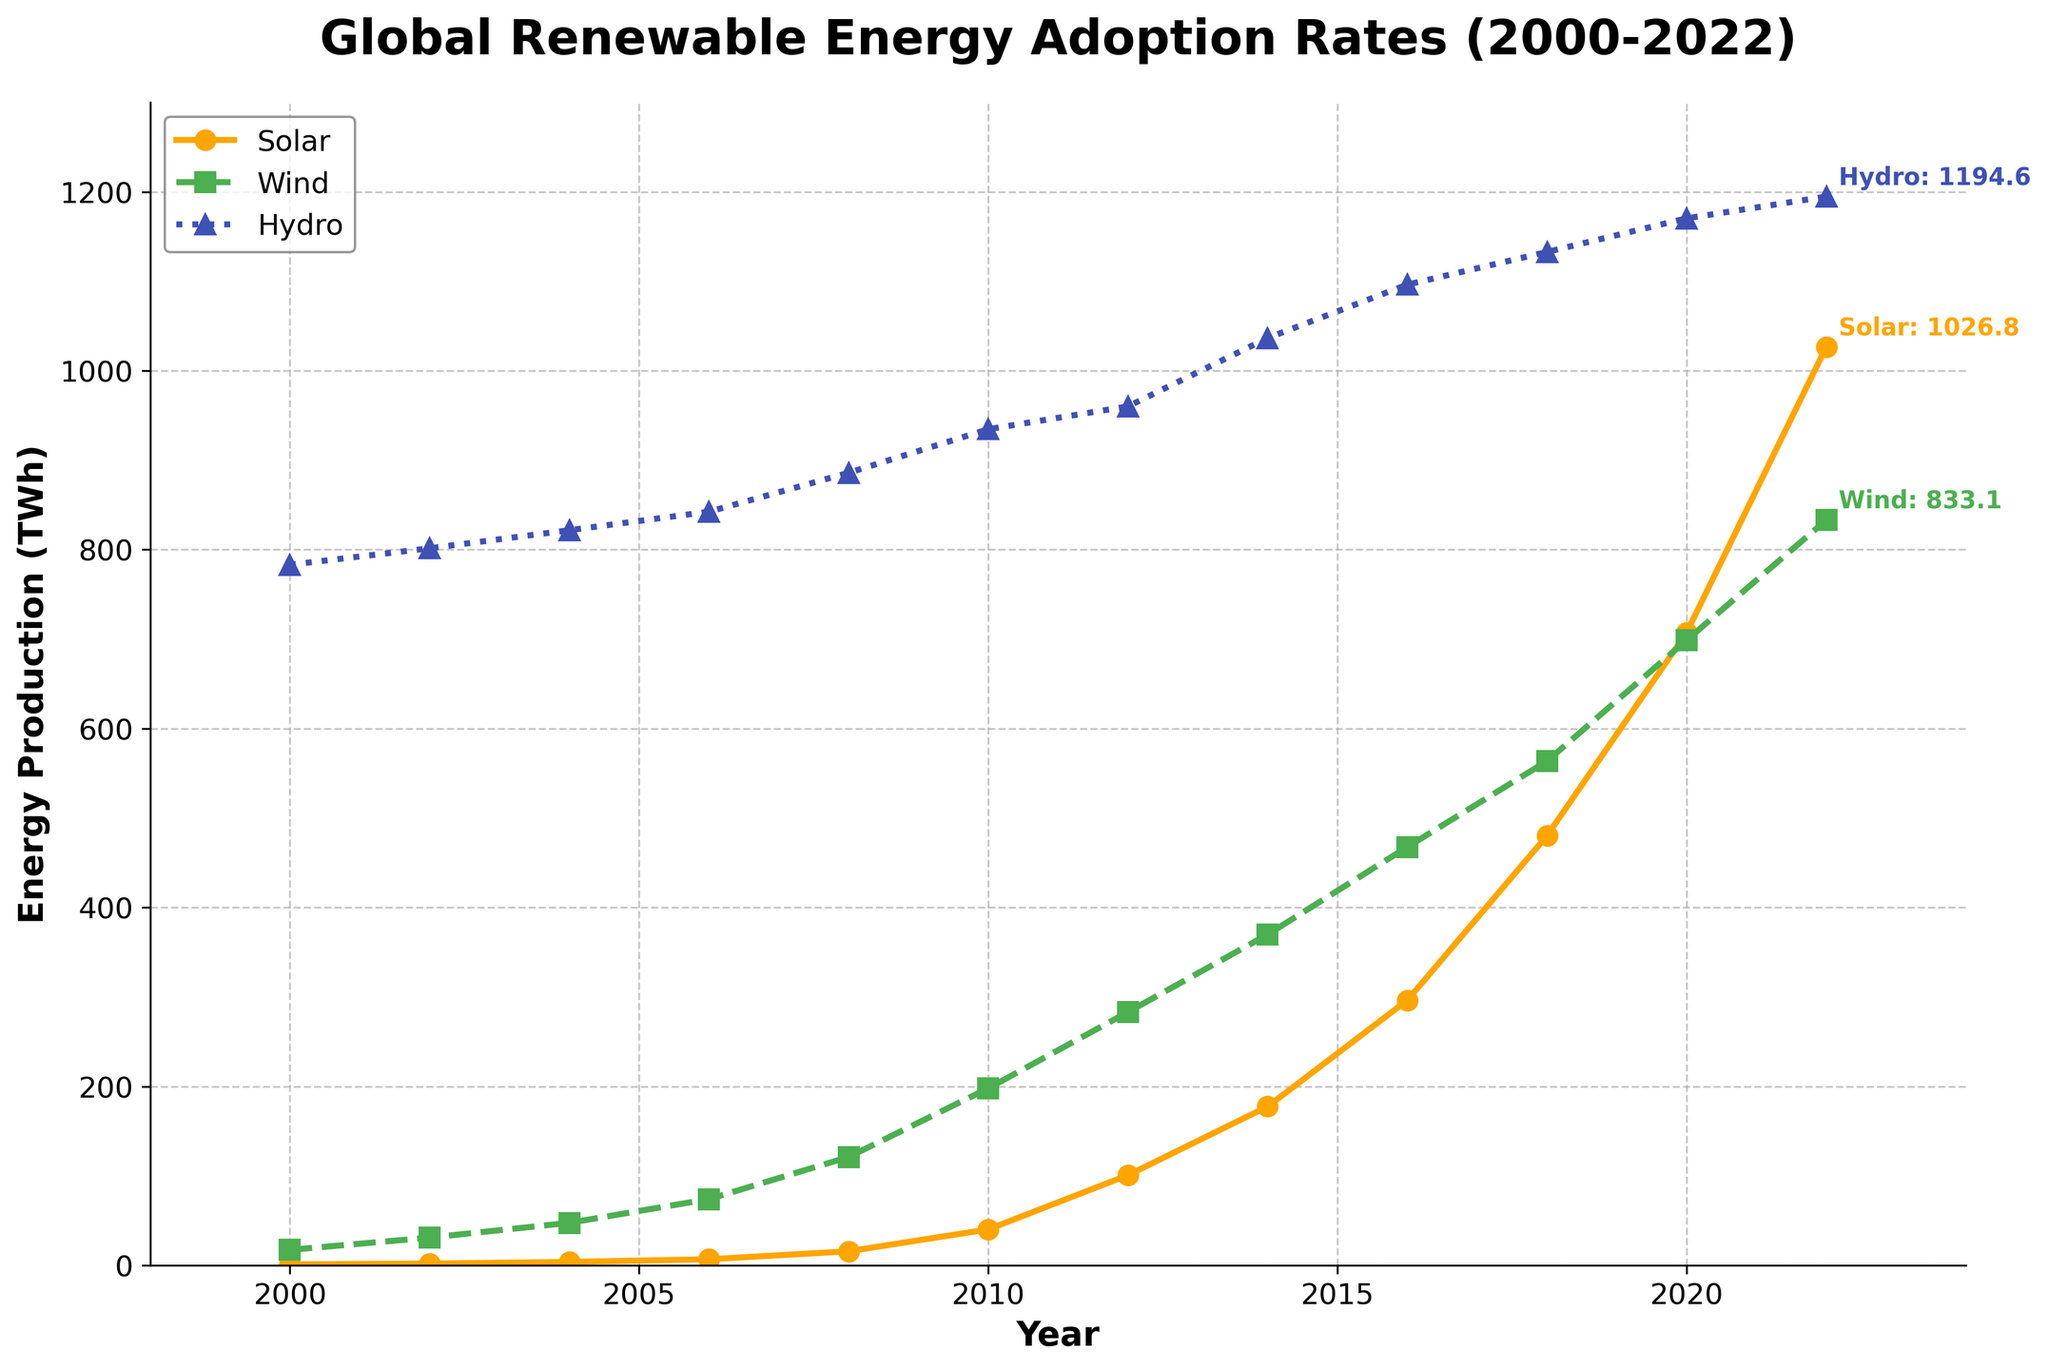What is the trend of solar energy adoption since 2000? The graph shows a consistent and steep increase in solar energy adoption rates from 1.2 TWh in 2000 to 1026.8 TWh in 2022. The adoption rate accelerates significantly after 2010.
Answer: Steady increase How much more wind energy was produced in 2022 compared to 2000? In 2000, wind energy production was 17.4 TWh, and in 2022 it was 833.1 TWh. The difference is 833.1 - 17.4 = 815.7 TWh.
Answer: 815.7 TWh What year saw the largest increase in solar energy production? By visually inspecting the steepness of the solar line, the largest year-on-year increase appears between 2010 and 2012. Solar energy increased from 40.3 TWh in 2010 to 100.9 TWh in 2012.
Answer: 2010-2012 Compare the growth rates of solar and wind energy between 2000 and 2022. Which grew faster? Solar energy increased from 1.2 TWh to 1026.8 TWh, and wind energy from 17.4 TWh to 833.1 TWh. Solar increased by (1026.8/1.2) ≈ 855.67 times, while wind increased by (833.1/17.4) ≈ 47.9 times. Hence, solar grew faster.
Answer: Solar What is the difference in total energy production between hydro and solar in 2022? In 2022, hydro energy production was 1194.6 TWh and solar was 1026.8 TWh. The difference is 1194.6 - 1026.8 = 167.8 TWh.
Answer: 167.8 TWh Which renewable energy source had the least variation in adoption rates from 2000 to 2022? Inspecting the graph visually, hydro energy shows the least variation as its increase is less steep and more gradual compared to the sharp increases in solar and wind.
Answer: Hydro What were the annual average growth rates for wind energy from 2000 to 2022? The wind energy grew from 17.4 TWh in 2000 to 833.1 TWh in 2022 over 22 years. The annual average growth rate \( r \) can be approximated by \((\frac{833.1}{17.4})^{\frac{1}{22}} - 1 \approx 0.167 \approx 16.7\% \).
Answer: 16.7% In which year did wind energy adoption surpass 500 TWh? The graph shows that wind energy production surpassed 500 TWh in 2018, when it reached 563.7 TWh.
Answer: 2018 What can be inferred about the slope of the hydro line compared to solar and wind from 2000 to 2022? Visually, the slope of the hydro line is much less steep compared to the solar and wind lines, indicating a slower growth rate in hydro energy adoption compared to the other two.
Answer: Slower growth Which renewable energy source was the dominant producer in 2000, and how has this changed by 2022? In 2000, hydro was the dominant producer at 783.1 TWh compared to solar (1.2 TWh) and wind (17.4 TWh). By 2022, despite substantial increases in solar and wind, hydro remains the dominant producer at 1194.6 TWh, more than solar (1026.8 TWh) and wind (833.1 TWh).
Answer: Hydro remained dominant 